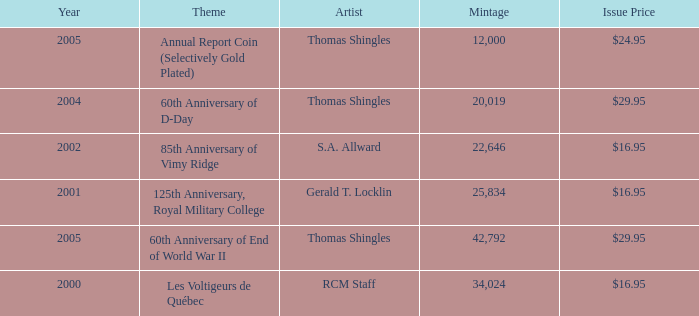What year was S.A. Allward's theme that had an issue price of $16.95 released? 2002.0. 